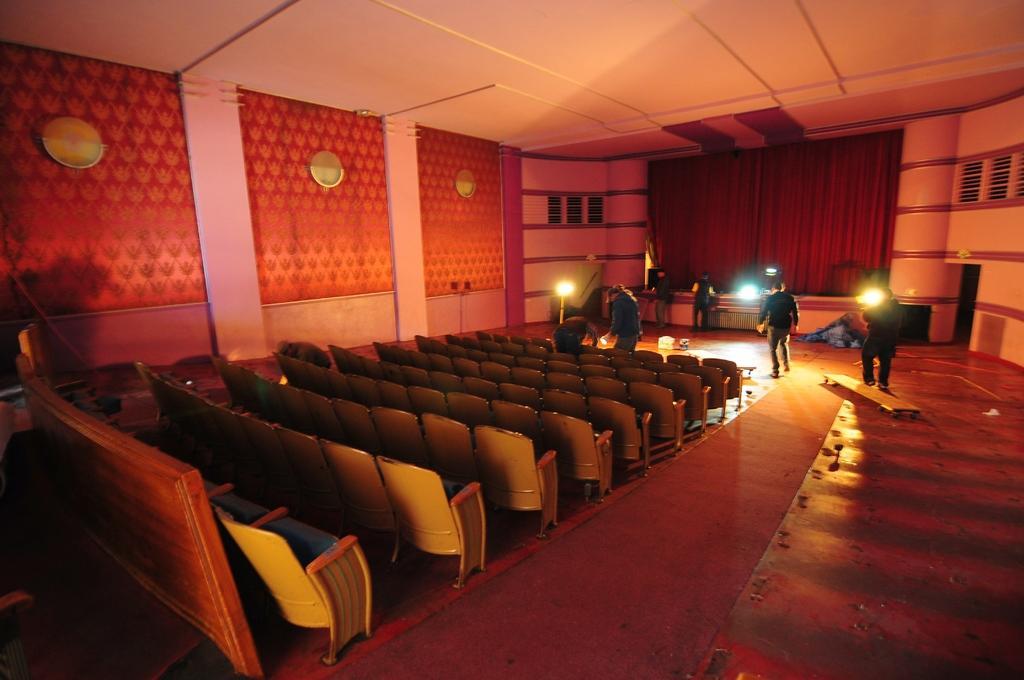Describe this image in one or two sentences. In this image there is a big hall with so many chairs and stage where people are standing we can also see there are some lights. 